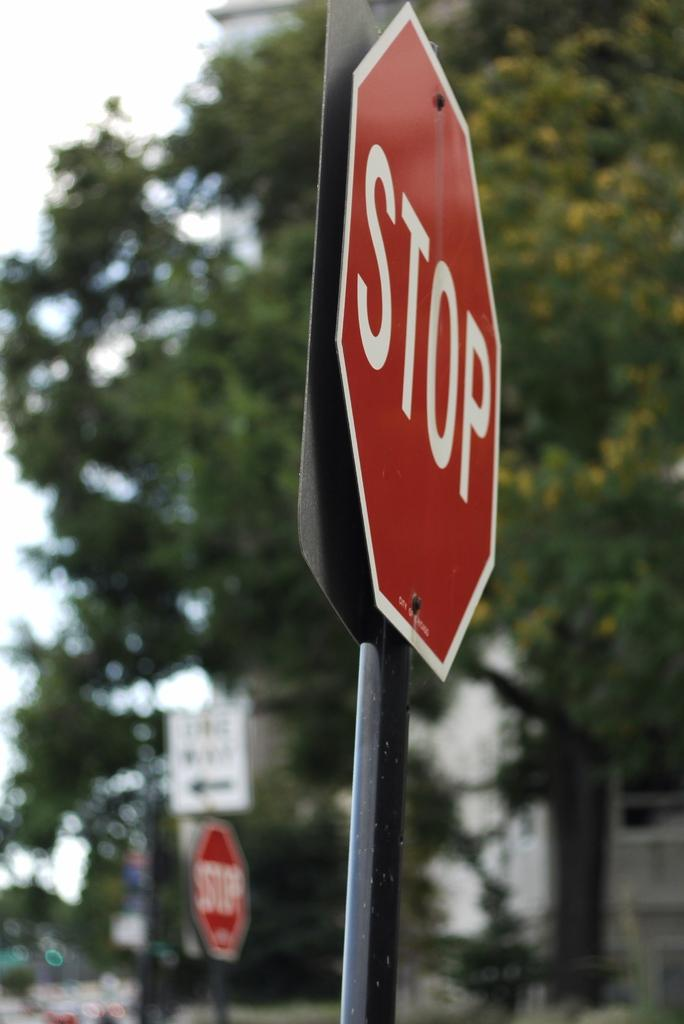<image>
Provide a brief description of the given image. A red stop sign facing right with a white sign in the background. 